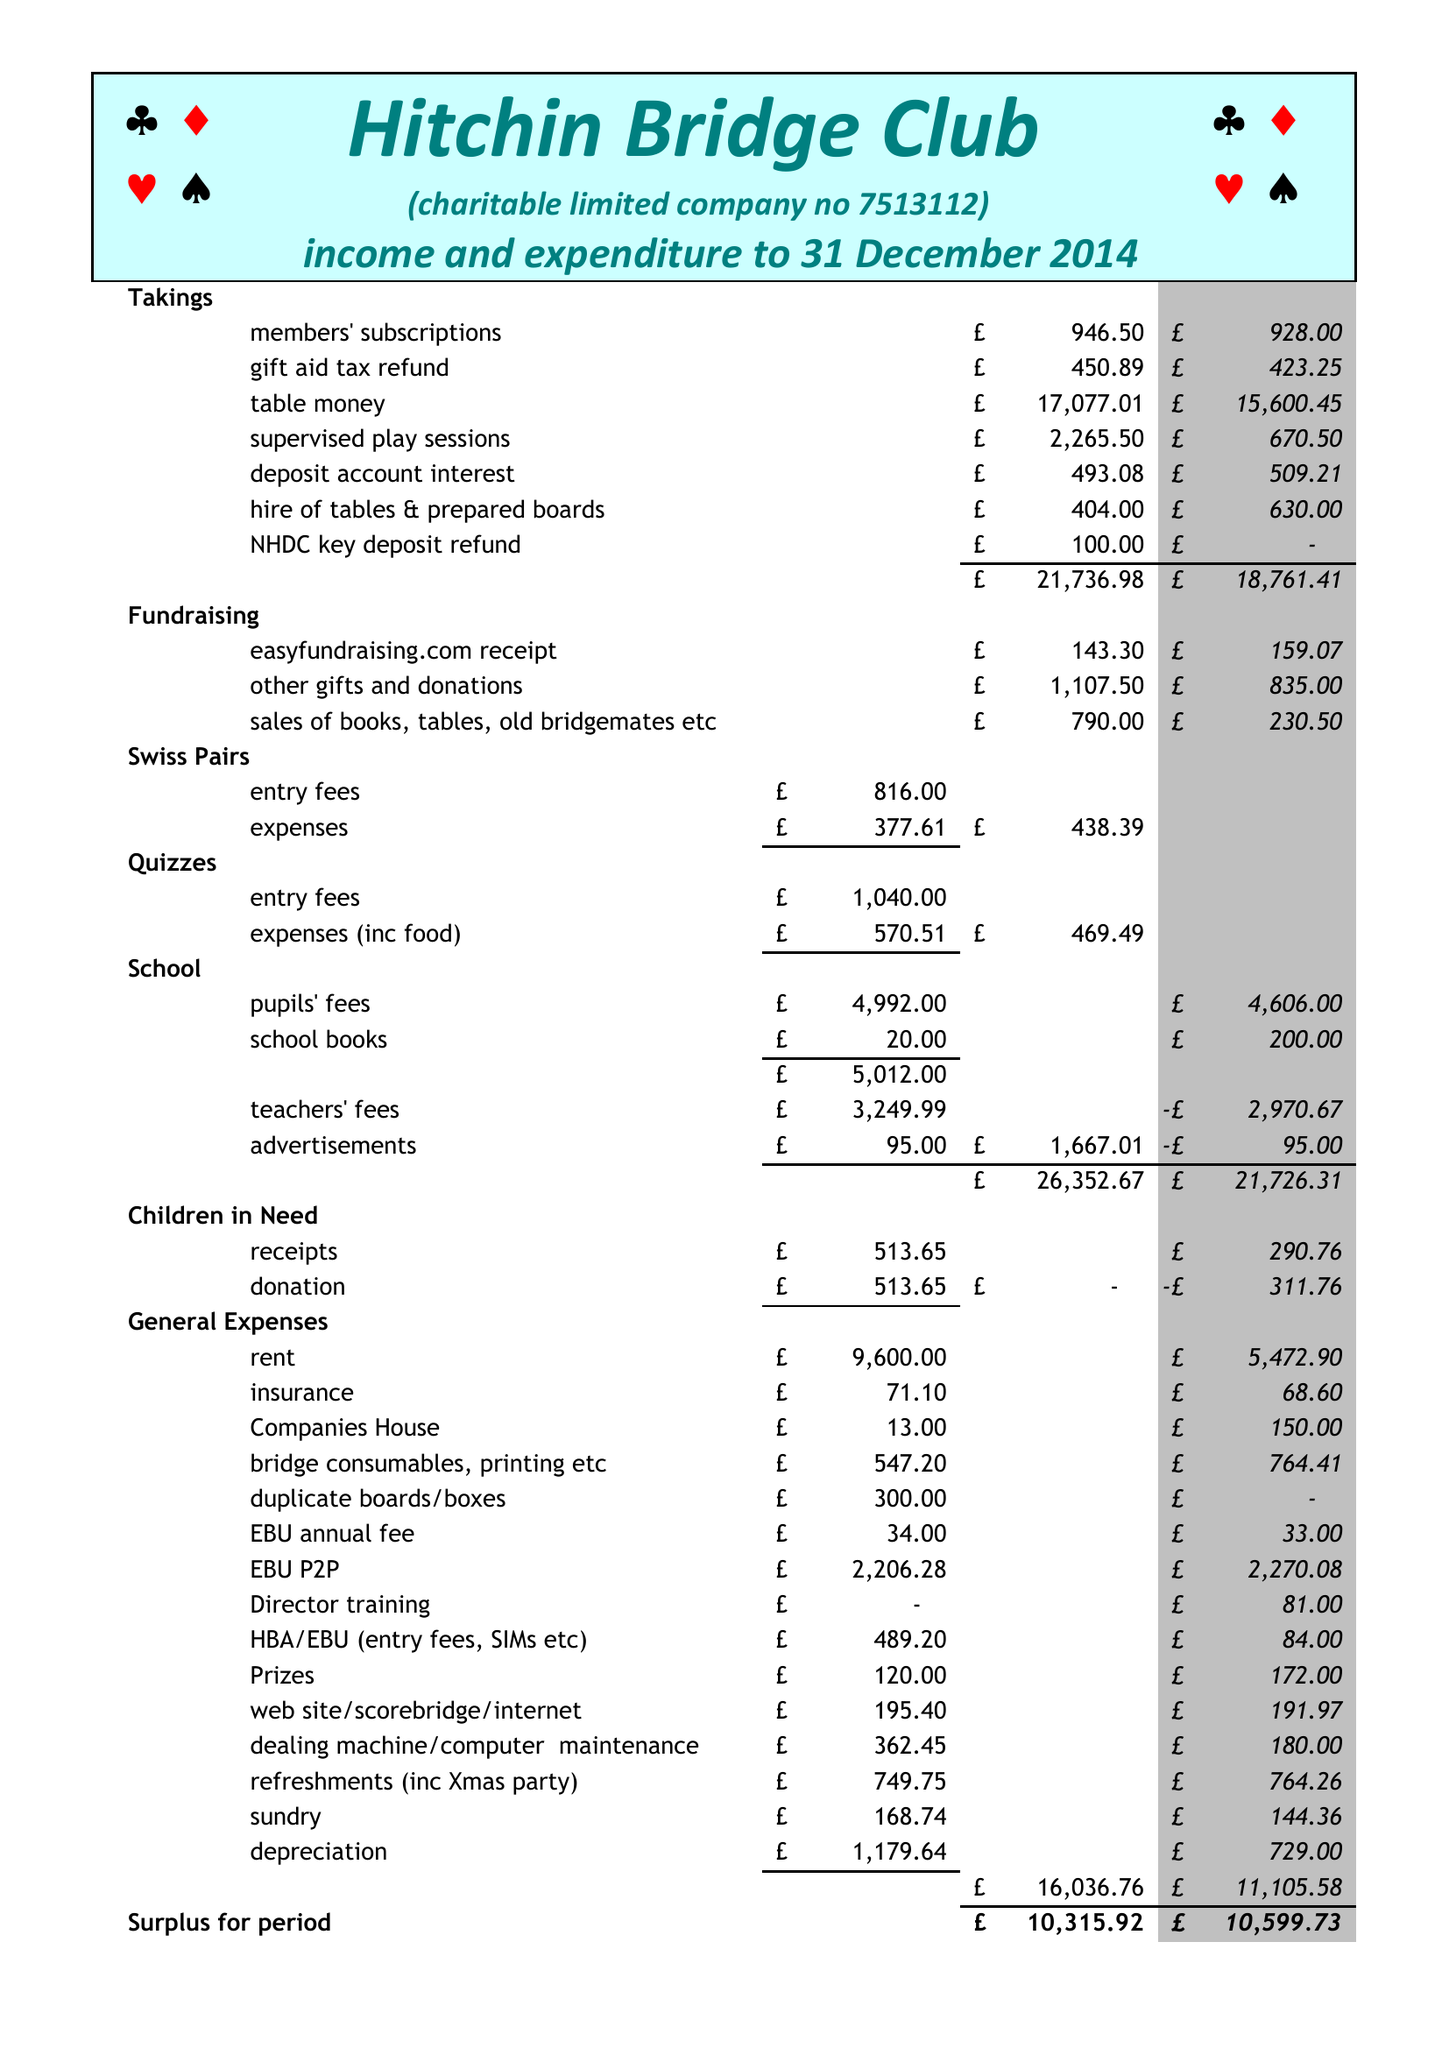What is the value for the charity_number?
Answer the question using a single word or phrase. 1140362 